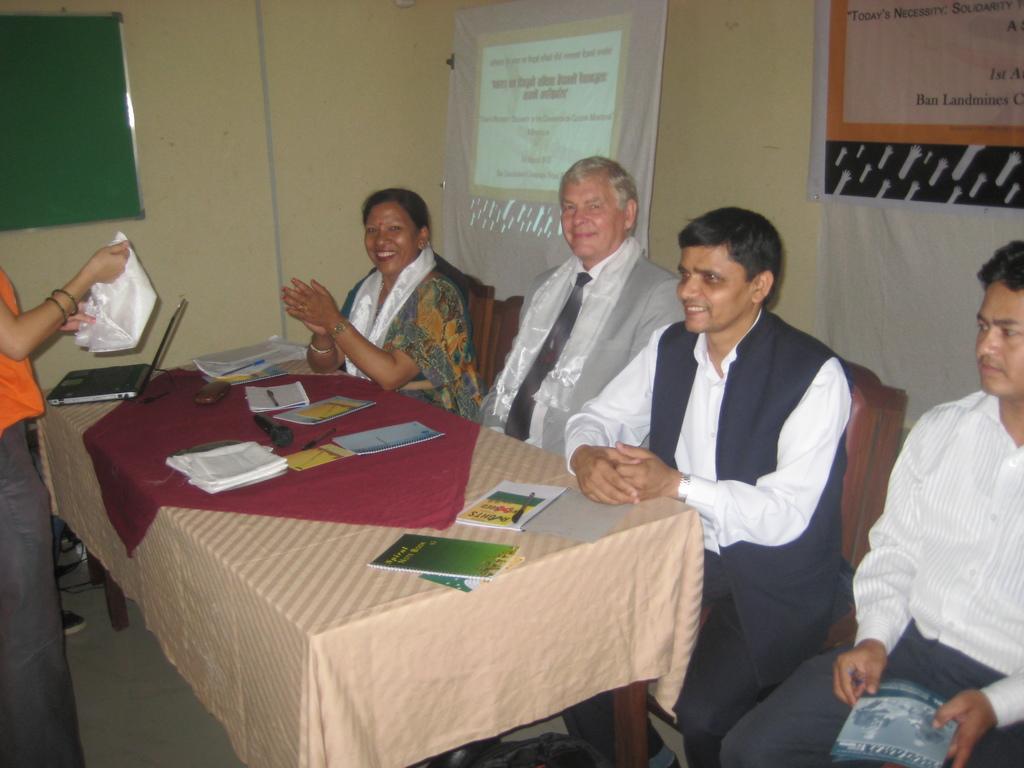Please provide a concise description of this image. There are many people sitting on chairs. And there is a table. On the table, there is a cloth and many books and laptop. And there is a wall in the background. On the wall there are banners and notices and a board. 